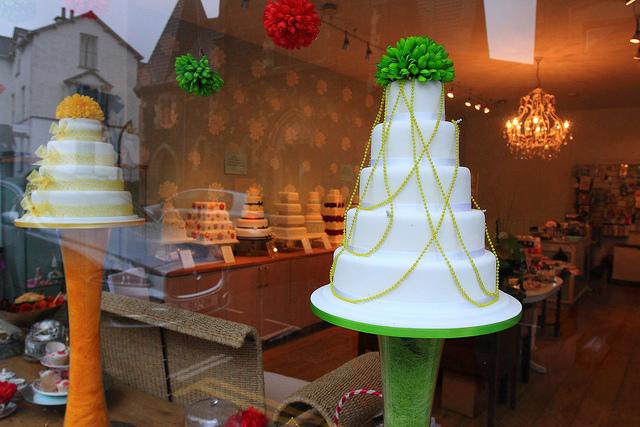Is there any ice cream?
Give a very brief answer. No. What type of dangling light fixture is in the shop?
Keep it brief. Chandelier. What type of shop is this?
Give a very brief answer. Bakery. 